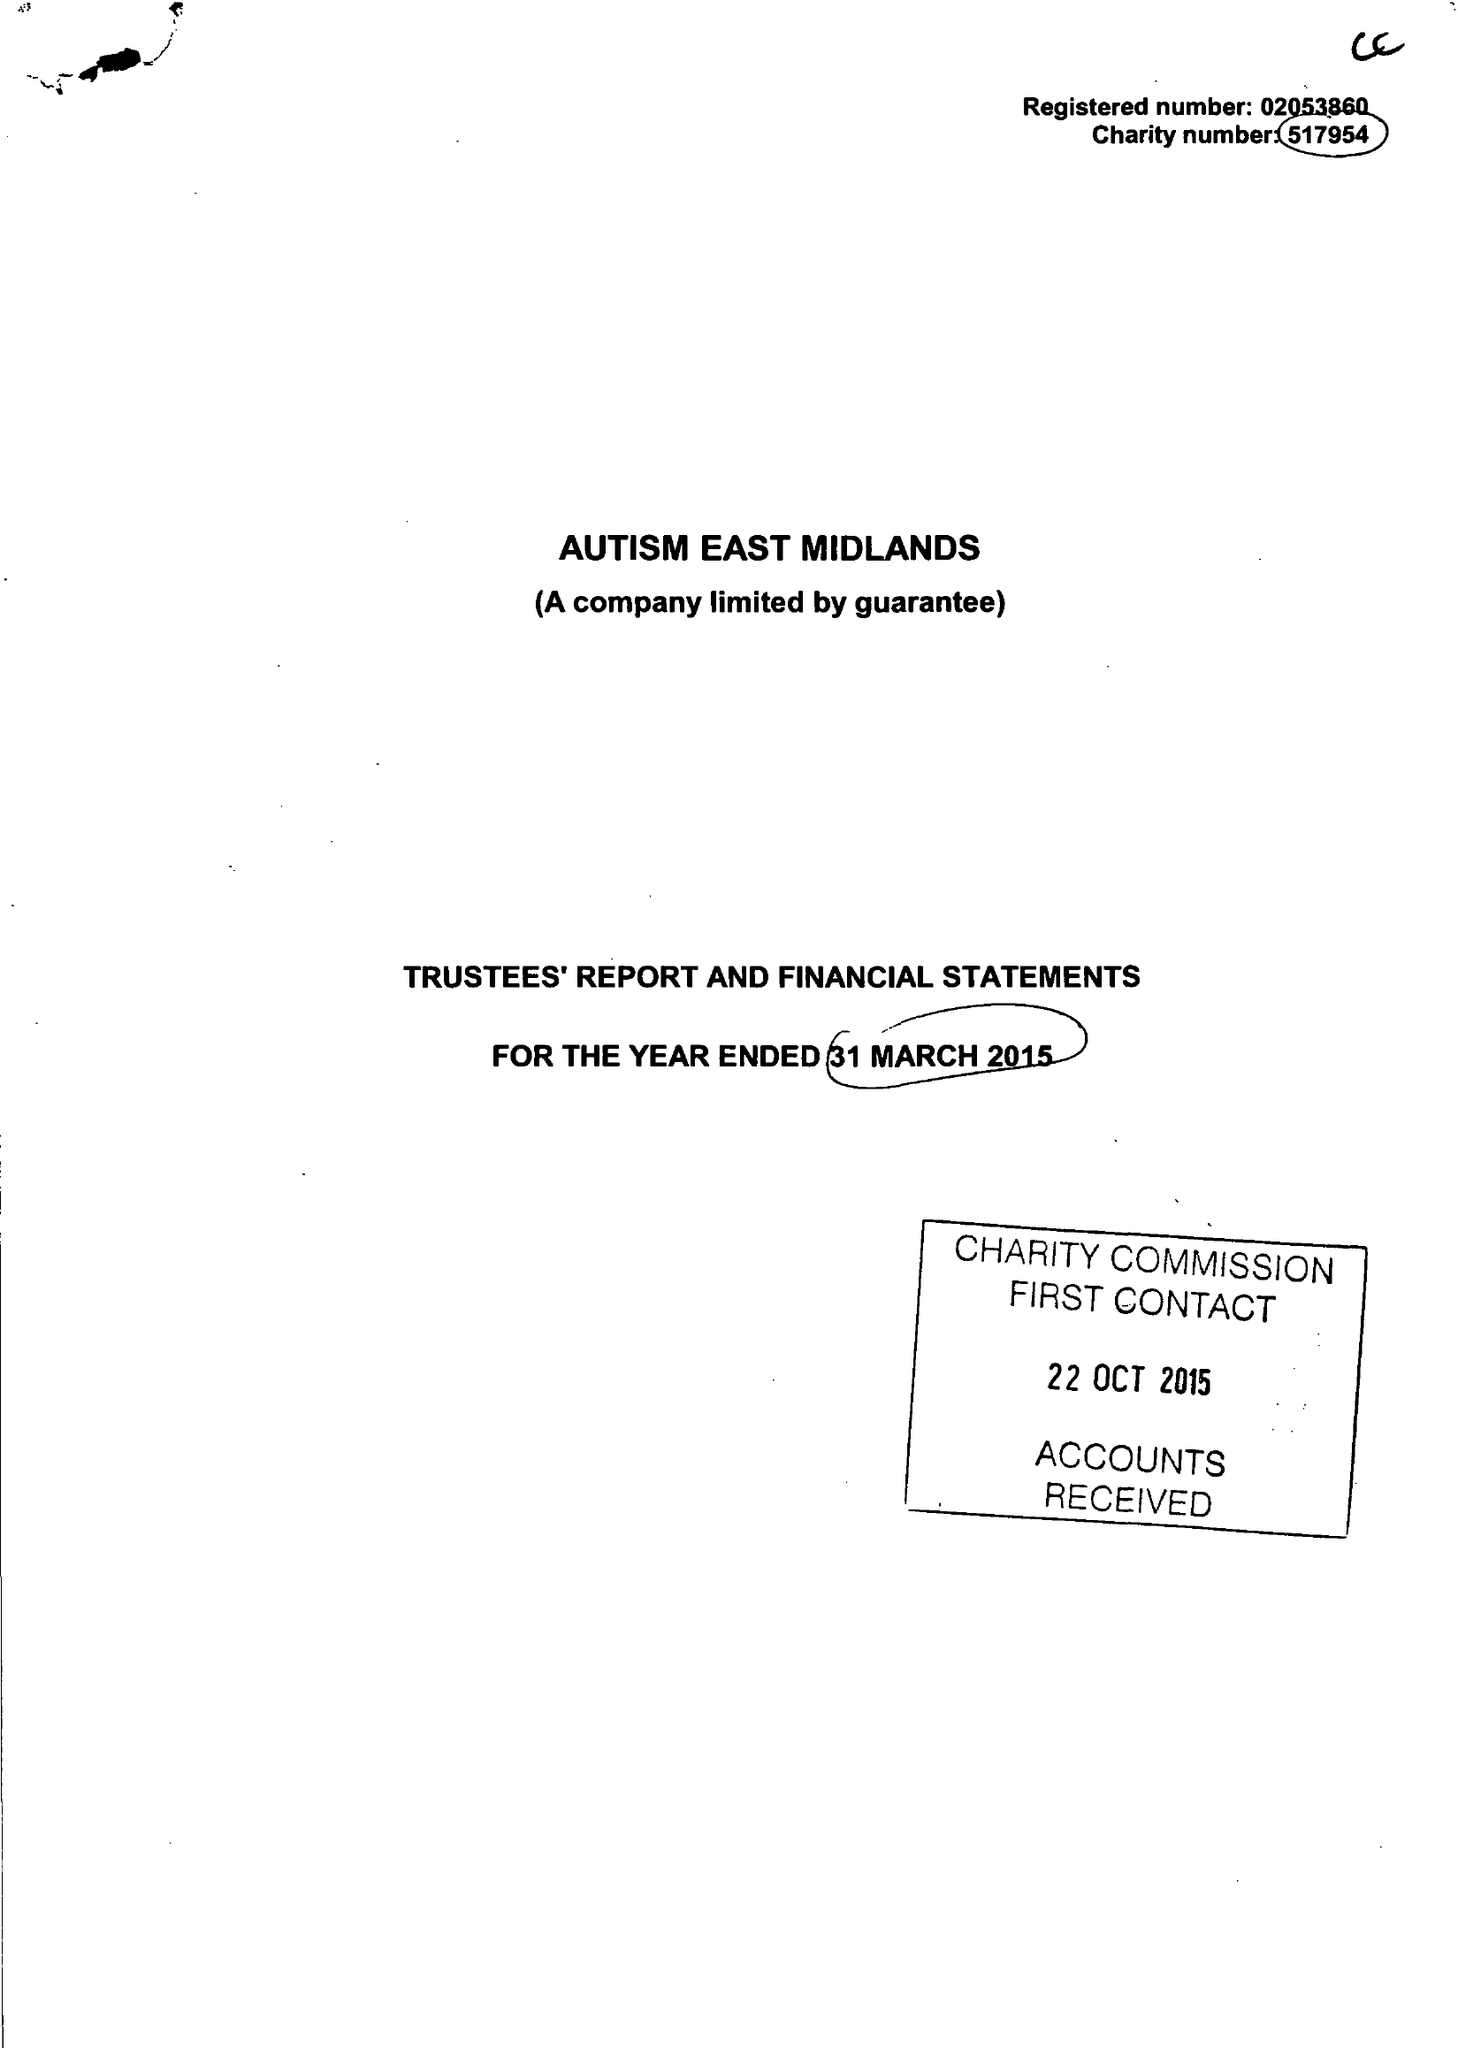What is the value for the charity_number?
Answer the question using a single word or phrase. 517954 